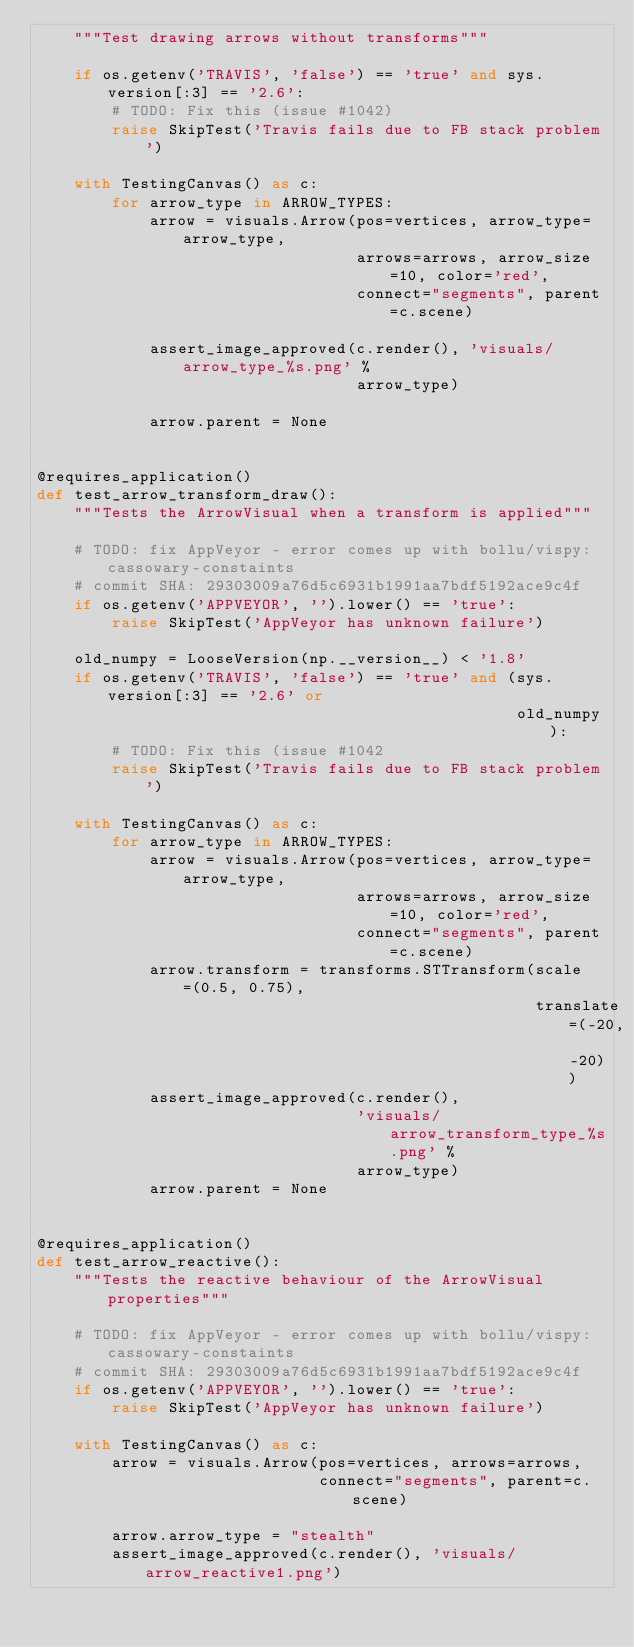Convert code to text. <code><loc_0><loc_0><loc_500><loc_500><_Python_>    """Test drawing arrows without transforms"""

    if os.getenv('TRAVIS', 'false') == 'true' and sys.version[:3] == '2.6':
        # TODO: Fix this (issue #1042)
        raise SkipTest('Travis fails due to FB stack problem')

    with TestingCanvas() as c:
        for arrow_type in ARROW_TYPES:
            arrow = visuals.Arrow(pos=vertices, arrow_type=arrow_type,
                                  arrows=arrows, arrow_size=10, color='red',
                                  connect="segments", parent=c.scene)

            assert_image_approved(c.render(), 'visuals/arrow_type_%s.png' %
                                  arrow_type)

            arrow.parent = None


@requires_application()
def test_arrow_transform_draw():
    """Tests the ArrowVisual when a transform is applied"""

    # TODO: fix AppVeyor - error comes up with bollu/vispy:cassowary-constaints
    # commit SHA: 29303009a76d5c6931b1991aa7bdf5192ace9c4f
    if os.getenv('APPVEYOR', '').lower() == 'true':
        raise SkipTest('AppVeyor has unknown failure')

    old_numpy = LooseVersion(np.__version__) < '1.8'
    if os.getenv('TRAVIS', 'false') == 'true' and (sys.version[:3] == '2.6' or
                                                   old_numpy):
        # TODO: Fix this (issue #1042
        raise SkipTest('Travis fails due to FB stack problem')

    with TestingCanvas() as c:
        for arrow_type in ARROW_TYPES:
            arrow = visuals.Arrow(pos=vertices, arrow_type=arrow_type,
                                  arrows=arrows, arrow_size=10, color='red',
                                  connect="segments", parent=c.scene)
            arrow.transform = transforms.STTransform(scale=(0.5, 0.75),
                                                     translate=(-20, -20))
            assert_image_approved(c.render(),
                                  'visuals/arrow_transform_type_%s.png' %
                                  arrow_type)
            arrow.parent = None


@requires_application()
def test_arrow_reactive():
    """Tests the reactive behaviour of the ArrowVisual properties"""

    # TODO: fix AppVeyor - error comes up with bollu/vispy:cassowary-constaints
    # commit SHA: 29303009a76d5c6931b1991aa7bdf5192ace9c4f
    if os.getenv('APPVEYOR', '').lower() == 'true':
        raise SkipTest('AppVeyor has unknown failure')

    with TestingCanvas() as c:
        arrow = visuals.Arrow(pos=vertices, arrows=arrows,
                              connect="segments", parent=c.scene)

        arrow.arrow_type = "stealth"
        assert_image_approved(c.render(), 'visuals/arrow_reactive1.png')
</code> 